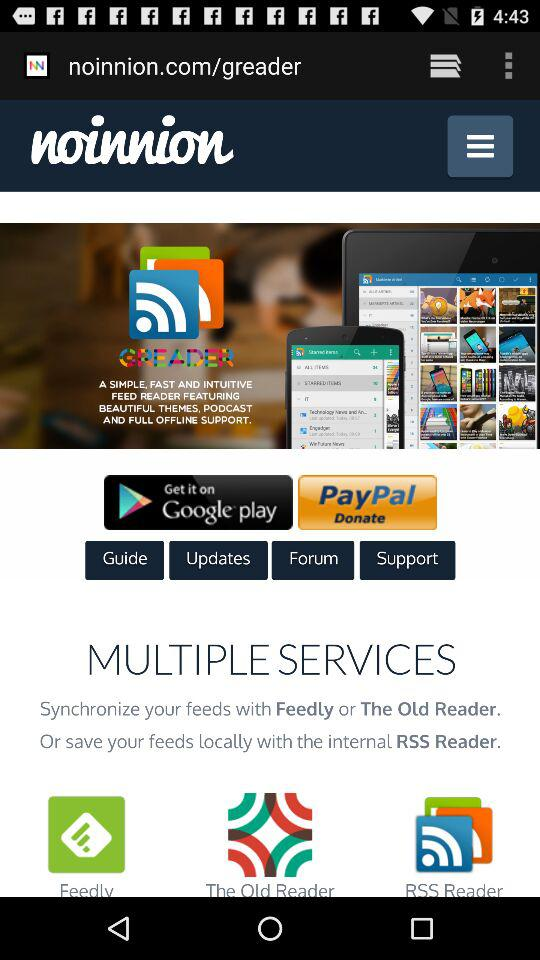How many services does noinnion support?
Answer the question using a single word or phrase. 3 